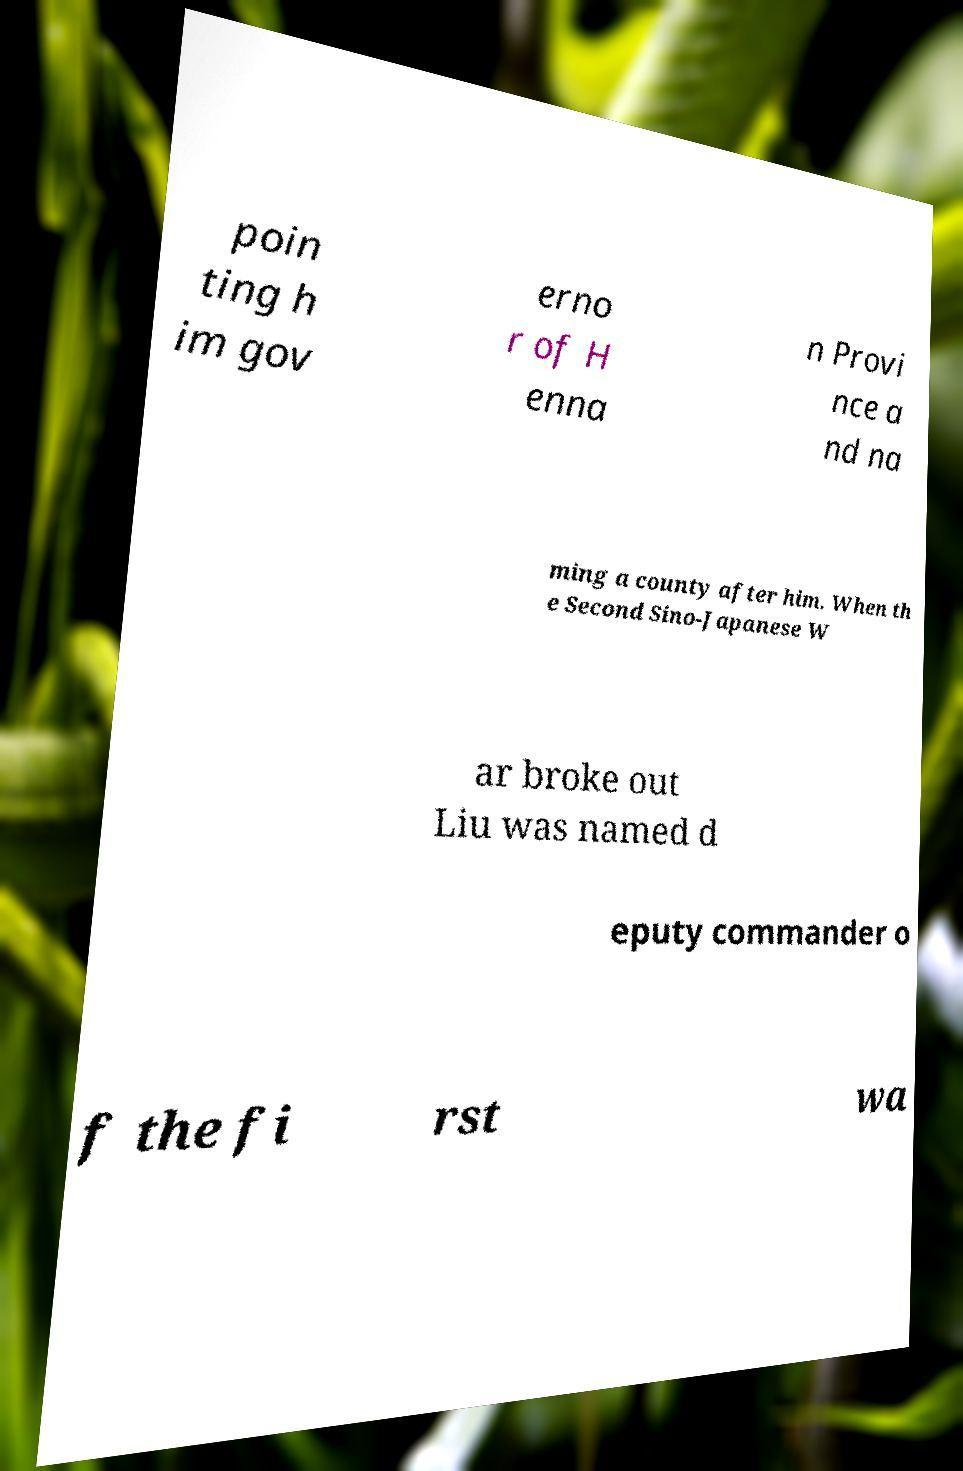What messages or text are displayed in this image? I need them in a readable, typed format. poin ting h im gov erno r of H enna n Provi nce a nd na ming a county after him. When th e Second Sino-Japanese W ar broke out Liu was named d eputy commander o f the fi rst wa 